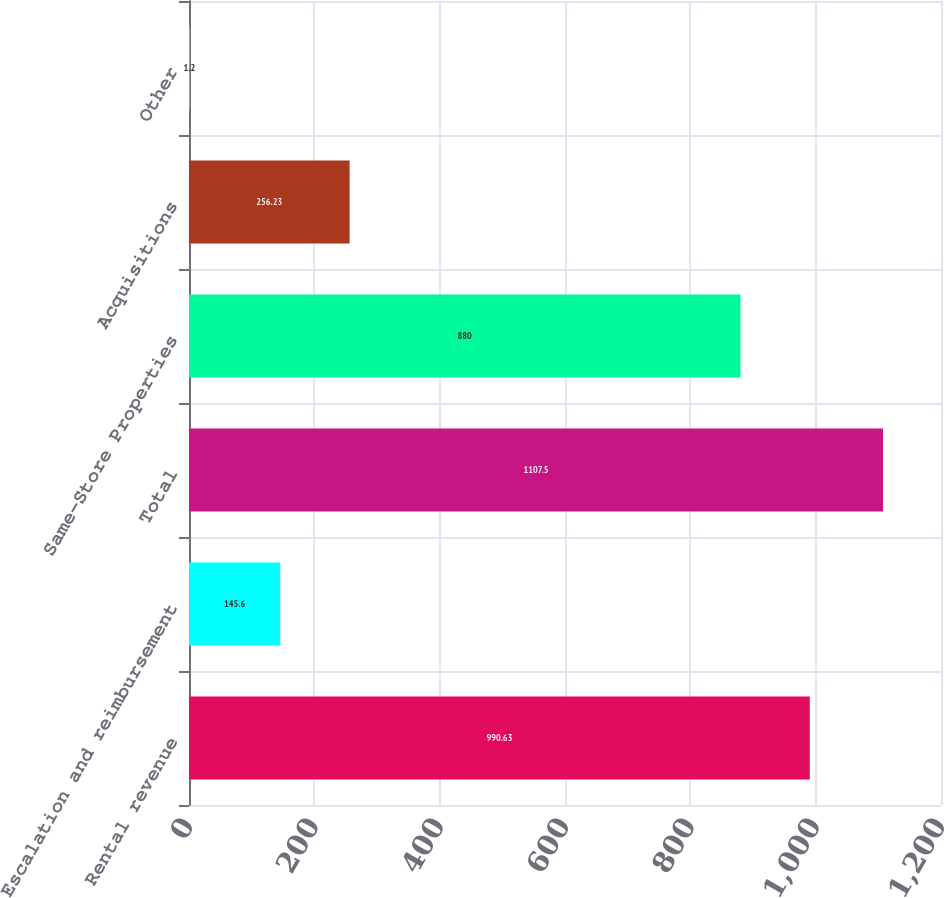<chart> <loc_0><loc_0><loc_500><loc_500><bar_chart><fcel>Rental revenue<fcel>Escalation and reimbursement<fcel>Total<fcel>Same-Store Properties<fcel>Acquisitions<fcel>Other<nl><fcel>990.63<fcel>145.6<fcel>1107.5<fcel>880<fcel>256.23<fcel>1.2<nl></chart> 